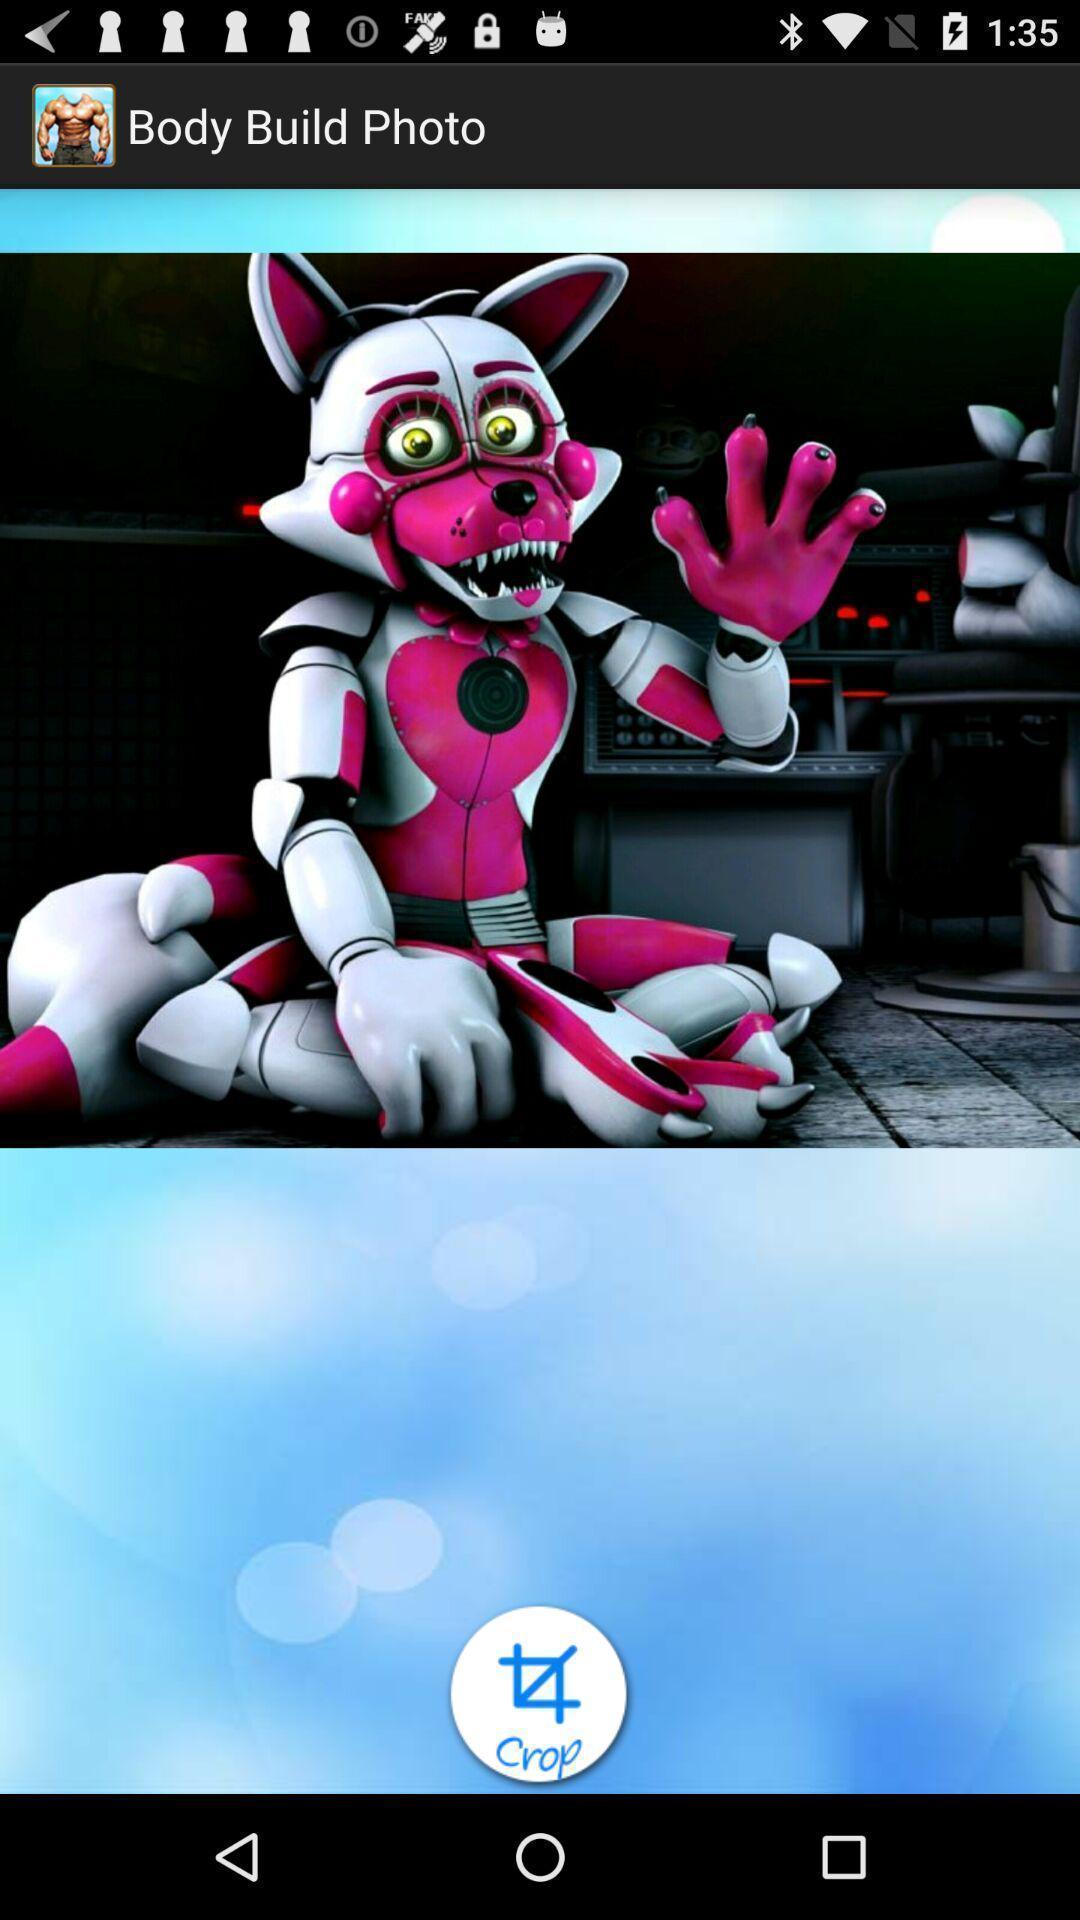Summarize the information in this screenshot. Screen showing image with crop option. 